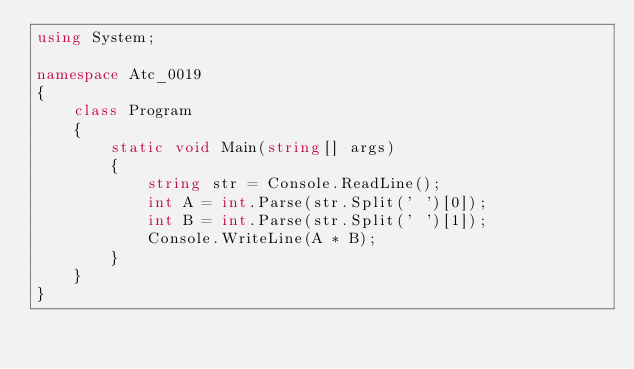Convert code to text. <code><loc_0><loc_0><loc_500><loc_500><_C#_>using System;

namespace Atc_0019
{
    class Program
    {
        static void Main(string[] args)
        {
            string str = Console.ReadLine();
            int A = int.Parse(str.Split(' ')[0]);
            int B = int.Parse(str.Split(' ')[1]);
            Console.WriteLine(A * B);
        }
    }
}
</code> 